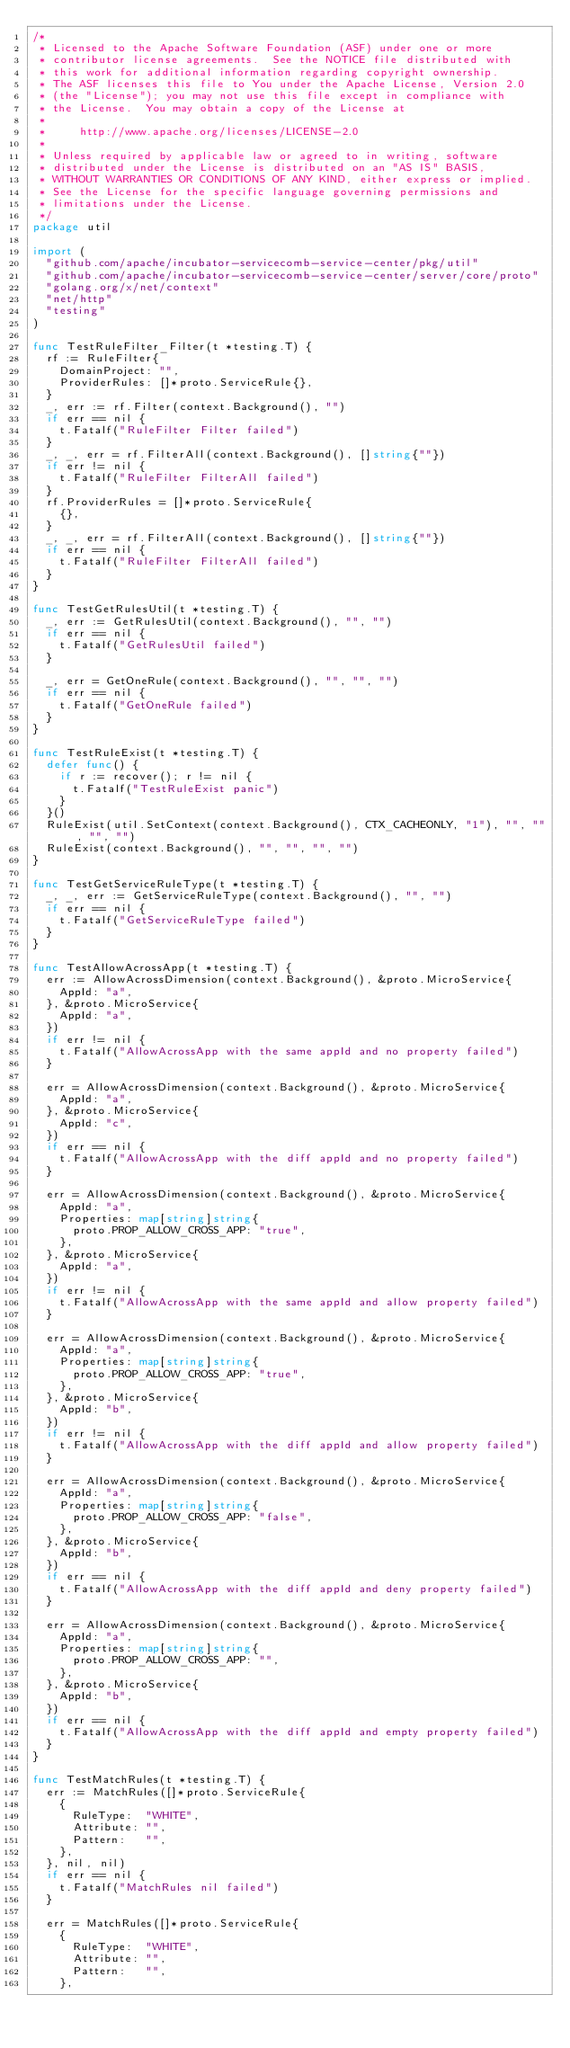<code> <loc_0><loc_0><loc_500><loc_500><_Go_>/*
 * Licensed to the Apache Software Foundation (ASF) under one or more
 * contributor license agreements.  See the NOTICE file distributed with
 * this work for additional information regarding copyright ownership.
 * The ASF licenses this file to You under the Apache License, Version 2.0
 * (the "License"); you may not use this file except in compliance with
 * the License.  You may obtain a copy of the License at
 *
 *     http://www.apache.org/licenses/LICENSE-2.0
 *
 * Unless required by applicable law or agreed to in writing, software
 * distributed under the License is distributed on an "AS IS" BASIS,
 * WITHOUT WARRANTIES OR CONDITIONS OF ANY KIND, either express or implied.
 * See the License for the specific language governing permissions and
 * limitations under the License.
 */
package util

import (
	"github.com/apache/incubator-servicecomb-service-center/pkg/util"
	"github.com/apache/incubator-servicecomb-service-center/server/core/proto"
	"golang.org/x/net/context"
	"net/http"
	"testing"
)

func TestRuleFilter_Filter(t *testing.T) {
	rf := RuleFilter{
		DomainProject: "",
		ProviderRules: []*proto.ServiceRule{},
	}
	_, err := rf.Filter(context.Background(), "")
	if err == nil {
		t.Fatalf("RuleFilter Filter failed")
	}
	_, _, err = rf.FilterAll(context.Background(), []string{""})
	if err != nil {
		t.Fatalf("RuleFilter FilterAll failed")
	}
	rf.ProviderRules = []*proto.ServiceRule{
		{},
	}
	_, _, err = rf.FilterAll(context.Background(), []string{""})
	if err == nil {
		t.Fatalf("RuleFilter FilterAll failed")
	}
}

func TestGetRulesUtil(t *testing.T) {
	_, err := GetRulesUtil(context.Background(), "", "")
	if err == nil {
		t.Fatalf("GetRulesUtil failed")
	}

	_, err = GetOneRule(context.Background(), "", "", "")
	if err == nil {
		t.Fatalf("GetOneRule failed")
	}
}

func TestRuleExist(t *testing.T) {
	defer func() {
		if r := recover(); r != nil {
			t.Fatalf("TestRuleExist panic")
		}
	}()
	RuleExist(util.SetContext(context.Background(), CTX_CACHEONLY, "1"), "", "", "", "")
	RuleExist(context.Background(), "", "", "", "")
}

func TestGetServiceRuleType(t *testing.T) {
	_, _, err := GetServiceRuleType(context.Background(), "", "")
	if err == nil {
		t.Fatalf("GetServiceRuleType failed")
	}
}

func TestAllowAcrossApp(t *testing.T) {
	err := AllowAcrossDimension(context.Background(), &proto.MicroService{
		AppId: "a",
	}, &proto.MicroService{
		AppId: "a",
	})
	if err != nil {
		t.Fatalf("AllowAcrossApp with the same appId and no property failed")
	}

	err = AllowAcrossDimension(context.Background(), &proto.MicroService{
		AppId: "a",
	}, &proto.MicroService{
		AppId: "c",
	})
	if err == nil {
		t.Fatalf("AllowAcrossApp with the diff appId and no property failed")
	}

	err = AllowAcrossDimension(context.Background(), &proto.MicroService{
		AppId: "a",
		Properties: map[string]string{
			proto.PROP_ALLOW_CROSS_APP: "true",
		},
	}, &proto.MicroService{
		AppId: "a",
	})
	if err != nil {
		t.Fatalf("AllowAcrossApp with the same appId and allow property failed")
	}

	err = AllowAcrossDimension(context.Background(), &proto.MicroService{
		AppId: "a",
		Properties: map[string]string{
			proto.PROP_ALLOW_CROSS_APP: "true",
		},
	}, &proto.MicroService{
		AppId: "b",
	})
	if err != nil {
		t.Fatalf("AllowAcrossApp with the diff appId and allow property failed")
	}

	err = AllowAcrossDimension(context.Background(), &proto.MicroService{
		AppId: "a",
		Properties: map[string]string{
			proto.PROP_ALLOW_CROSS_APP: "false",
		},
	}, &proto.MicroService{
		AppId: "b",
	})
	if err == nil {
		t.Fatalf("AllowAcrossApp with the diff appId and deny property failed")
	}

	err = AllowAcrossDimension(context.Background(), &proto.MicroService{
		AppId: "a",
		Properties: map[string]string{
			proto.PROP_ALLOW_CROSS_APP: "",
		},
	}, &proto.MicroService{
		AppId: "b",
	})
	if err == nil {
		t.Fatalf("AllowAcrossApp with the diff appId and empty property failed")
	}
}

func TestMatchRules(t *testing.T) {
	err := MatchRules([]*proto.ServiceRule{
		{
			RuleType:  "WHITE",
			Attribute: "",
			Pattern:   "",
		},
	}, nil, nil)
	if err == nil {
		t.Fatalf("MatchRules nil failed")
	}

	err = MatchRules([]*proto.ServiceRule{
		{
			RuleType:  "WHITE",
			Attribute: "",
			Pattern:   "",
		},</code> 